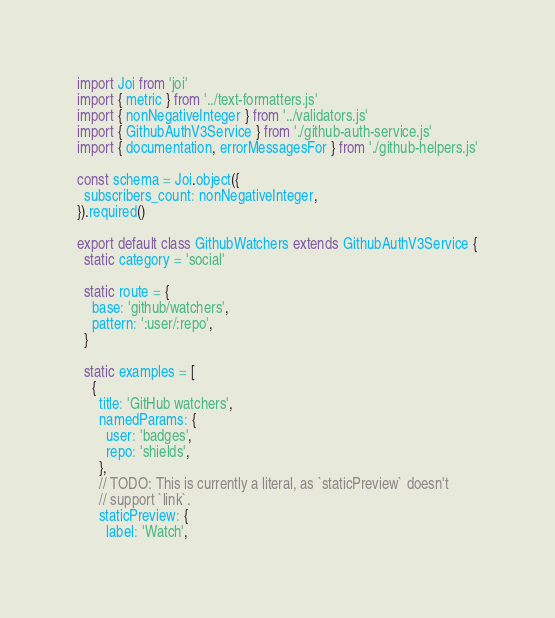Convert code to text. <code><loc_0><loc_0><loc_500><loc_500><_JavaScript_>import Joi from 'joi'
import { metric } from '../text-formatters.js'
import { nonNegativeInteger } from '../validators.js'
import { GithubAuthV3Service } from './github-auth-service.js'
import { documentation, errorMessagesFor } from './github-helpers.js'

const schema = Joi.object({
  subscribers_count: nonNegativeInteger,
}).required()

export default class GithubWatchers extends GithubAuthV3Service {
  static category = 'social'

  static route = {
    base: 'github/watchers',
    pattern: ':user/:repo',
  }

  static examples = [
    {
      title: 'GitHub watchers',
      namedParams: {
        user: 'badges',
        repo: 'shields',
      },
      // TODO: This is currently a literal, as `staticPreview` doesn't
      // support `link`.
      staticPreview: {
        label: 'Watch',</code> 